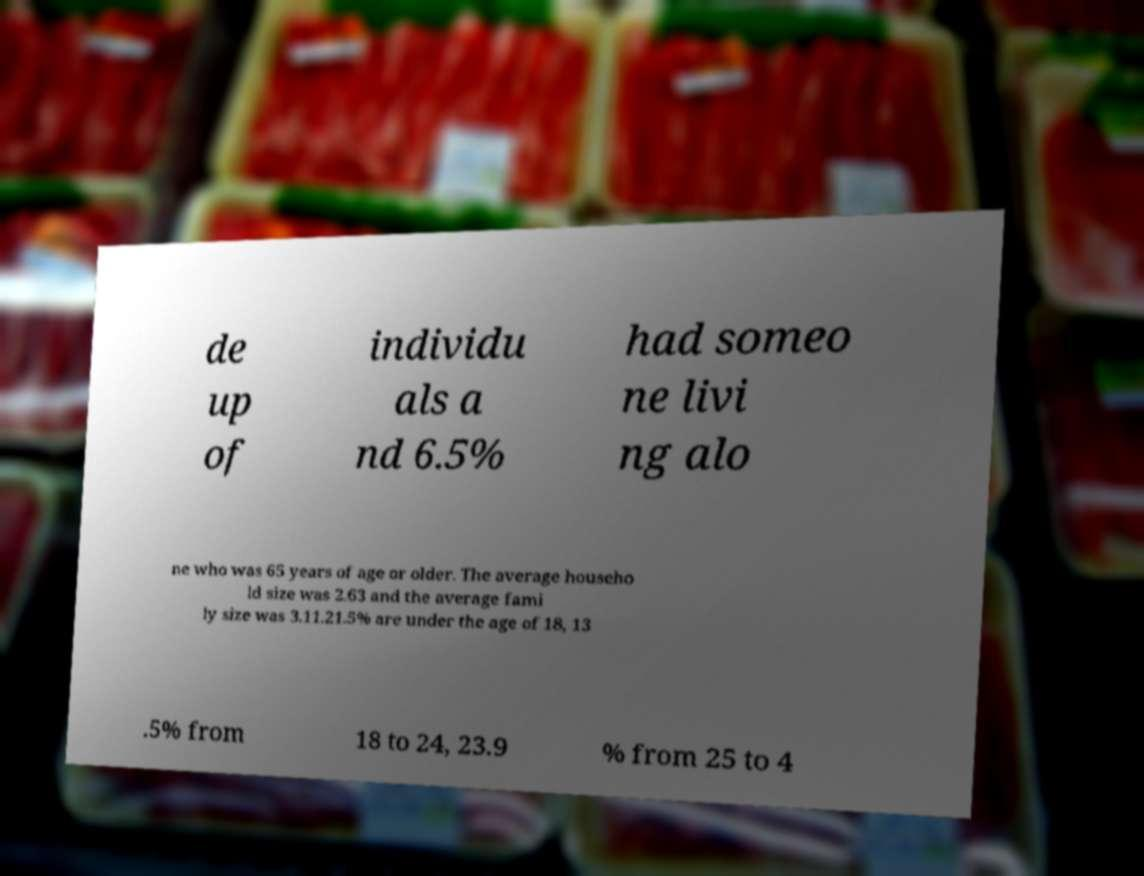Please read and relay the text visible in this image. What does it say? de up of individu als a nd 6.5% had someo ne livi ng alo ne who was 65 years of age or older. The average househo ld size was 2.63 and the average fami ly size was 3.11.21.5% are under the age of 18, 13 .5% from 18 to 24, 23.9 % from 25 to 4 